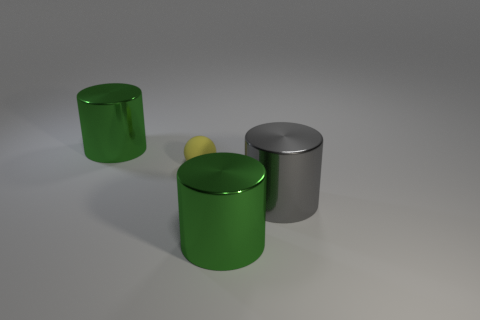Subtract all green cylinders. How many were subtracted if there are1green cylinders left? 1 Add 4 rubber things. How many objects exist? 8 Subtract all balls. How many objects are left? 3 Subtract 0 blue cylinders. How many objects are left? 4 Subtract all metallic things. Subtract all small yellow rubber objects. How many objects are left? 0 Add 3 large gray cylinders. How many large gray cylinders are left? 4 Add 1 yellow matte objects. How many yellow matte objects exist? 2 